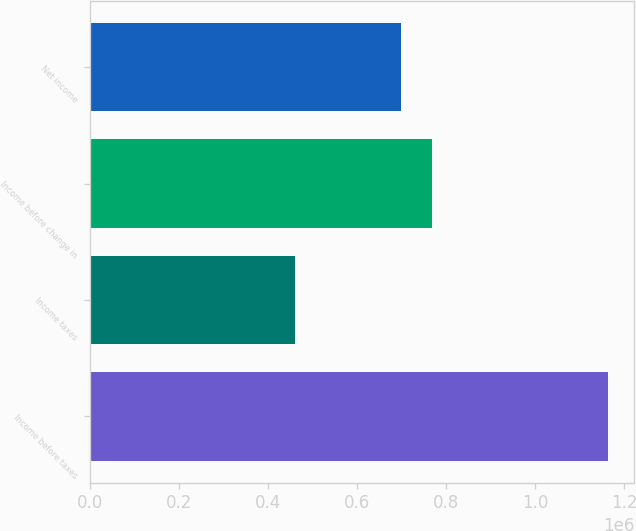Convert chart. <chart><loc_0><loc_0><loc_500><loc_500><bar_chart><fcel>Income before taxes<fcel>Income taxes<fcel>Income before change in<fcel>Net income<nl><fcel>1.16416e+06<fcel>459901<fcel>768323<fcel>697897<nl></chart> 